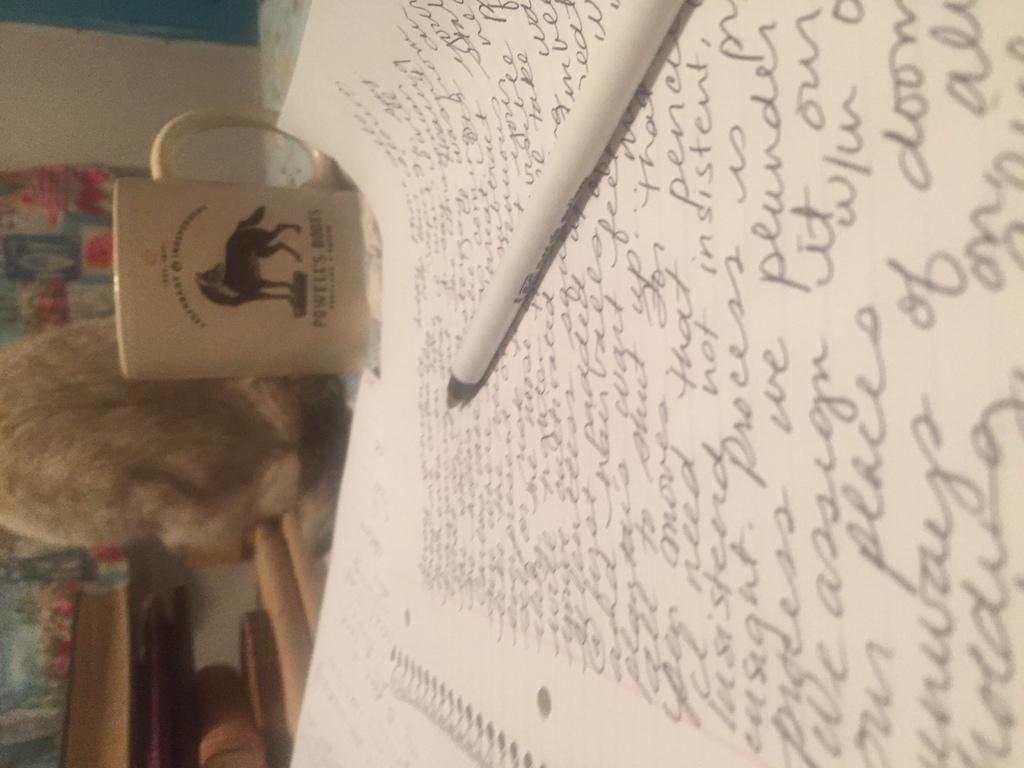What type of items can be seen in the image? There are books, a paper with text, a pen, and a cup in the image. What might be used for writing in the image? The pen in the image can be used for writing. What is the background of the image? There is a wall in the background of the image, and a cloth is hanging on the wall. How many unspecified objects are present in the image? There are a few unspecified objects in the image. What type of instrument is being played in the image? There is no instrument being played in the image; the focus is on writing materials and unspecified objects. 